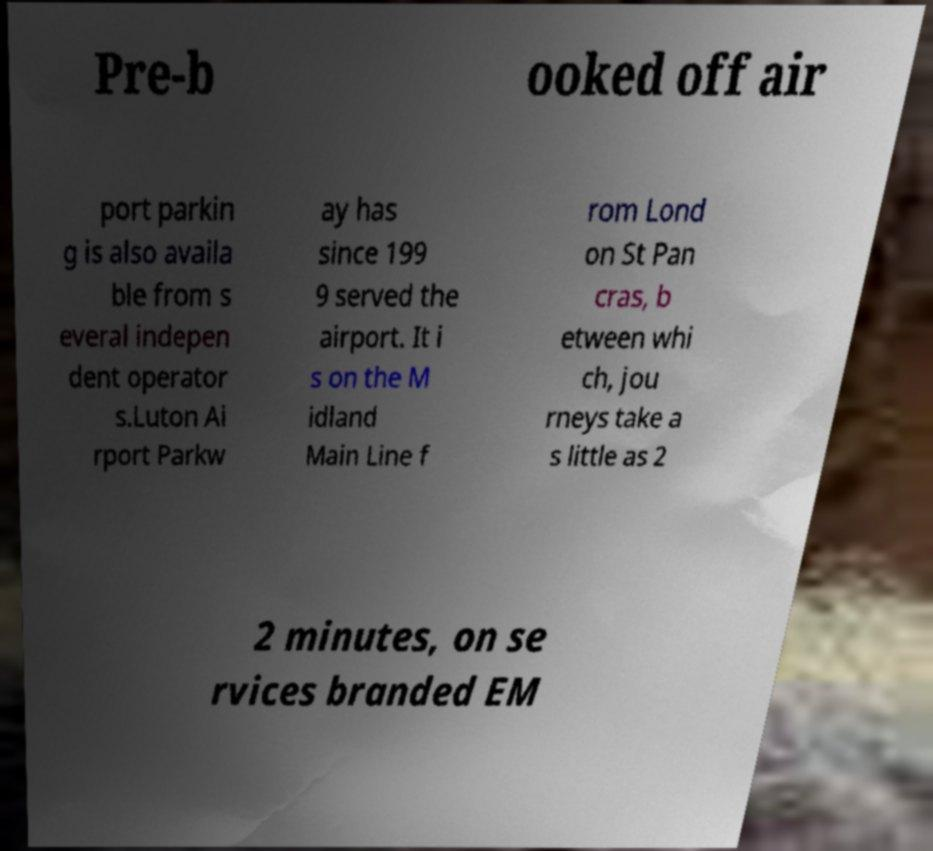Please read and relay the text visible in this image. What does it say? Pre-b ooked off air port parkin g is also availa ble from s everal indepen dent operator s.Luton Ai rport Parkw ay has since 199 9 served the airport. It i s on the M idland Main Line f rom Lond on St Pan cras, b etween whi ch, jou rneys take a s little as 2 2 minutes, on se rvices branded EM 